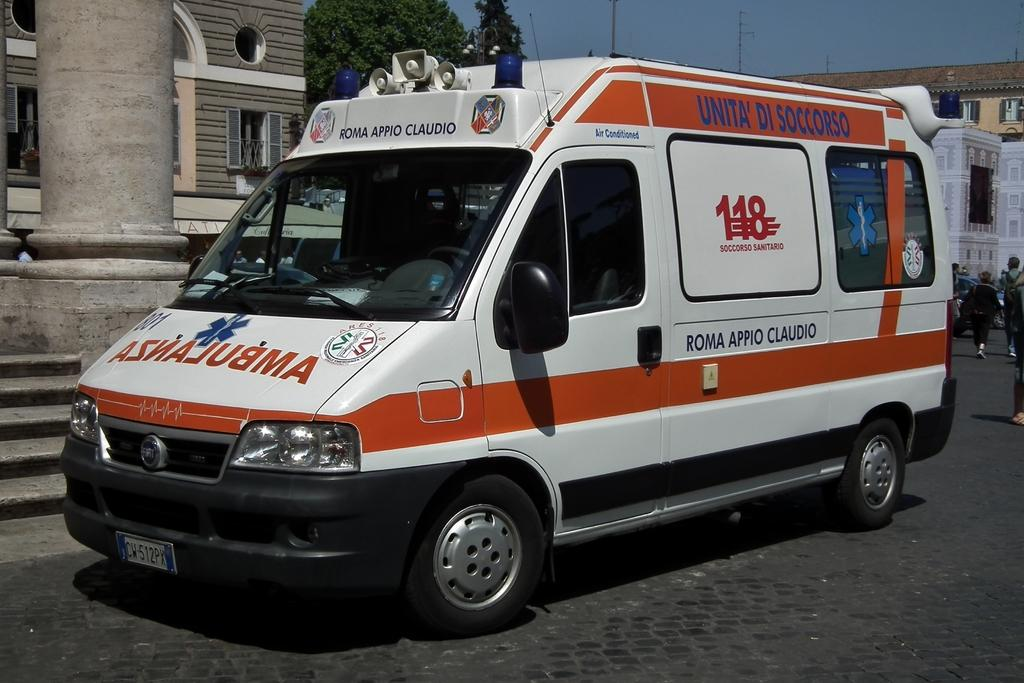What is parked on the road in the image? There is a vehicle parked on the road in the image. What can be seen in the background of the image? There is a group of people, a group of trees, buildings, and the sky visible in the background of the image. What type of locket is hanging from the tree in the image? There is no locket present in the image; it features a parked vehicle and various elements in the background. How many pigs are visible in the image? There are no pigs present in the image. 